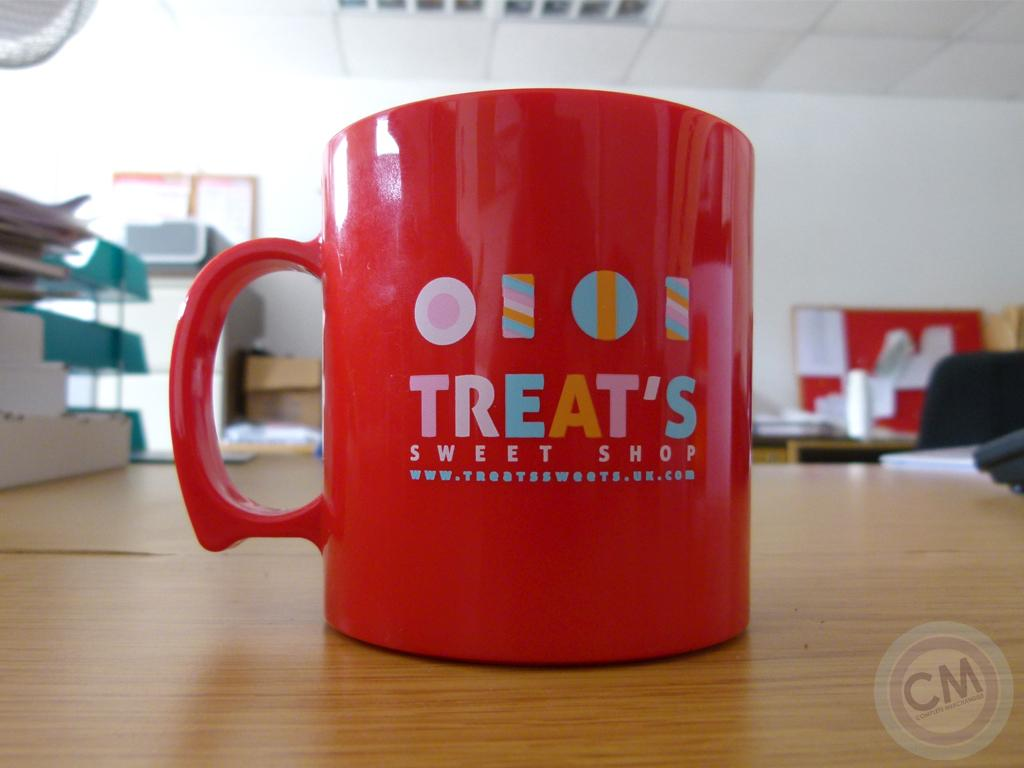<image>
Offer a succinct explanation of the picture presented. Red cup that says "Treats" on top of a wooden table. 